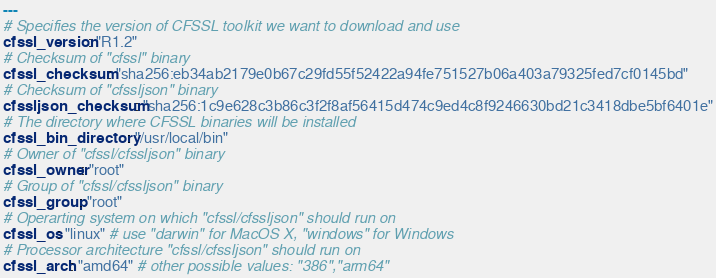<code> <loc_0><loc_0><loc_500><loc_500><_YAML_>---
# Specifies the version of CFSSL toolkit we want to download and use
cfssl_version: "R1.2"
# Checksum of "cfssl" binary
cfssl_checksum: "sha256:eb34ab2179e0b67c29fd55f52422a94fe751527b06a403a79325fed7cf0145bd"
# Checksum of "cfssljson" binary
cfssljson_checksum: "sha256:1c9e628c3b86c3f2f8af56415d474c9ed4c8f9246630bd21c3418dbe5bf6401e"
# The directory where CFSSL binaries will be installed
cfssl_bin_directory: "/usr/local/bin"
# Owner of "cfssl/cfssljson" binary
cfssl_owner: "root"
# Group of "cfssl/cfssljson" binary
cfssl_group: "root"
# Operarting system on which "cfssl/cfssljson" should run on
cfssl_os: "linux" # use "darwin" for MacOS X, "windows" for Windows
# Processor architecture "cfssl/cfssljson" should run on
cfssl_arch: "amd64" # other possible values: "386","arm64"

</code> 